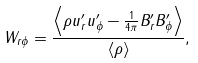Convert formula to latex. <formula><loc_0><loc_0><loc_500><loc_500>W _ { r \phi } = \frac { { \left \langle { \rho u _ { r } ^ { \prime } u _ { \phi } ^ { \prime } - \frac { 1 } { 4 \pi } B _ { r } ^ { \prime } B _ { \phi } ^ { \prime } } \right \rangle } } { \langle \rho \rangle } ,</formula> 